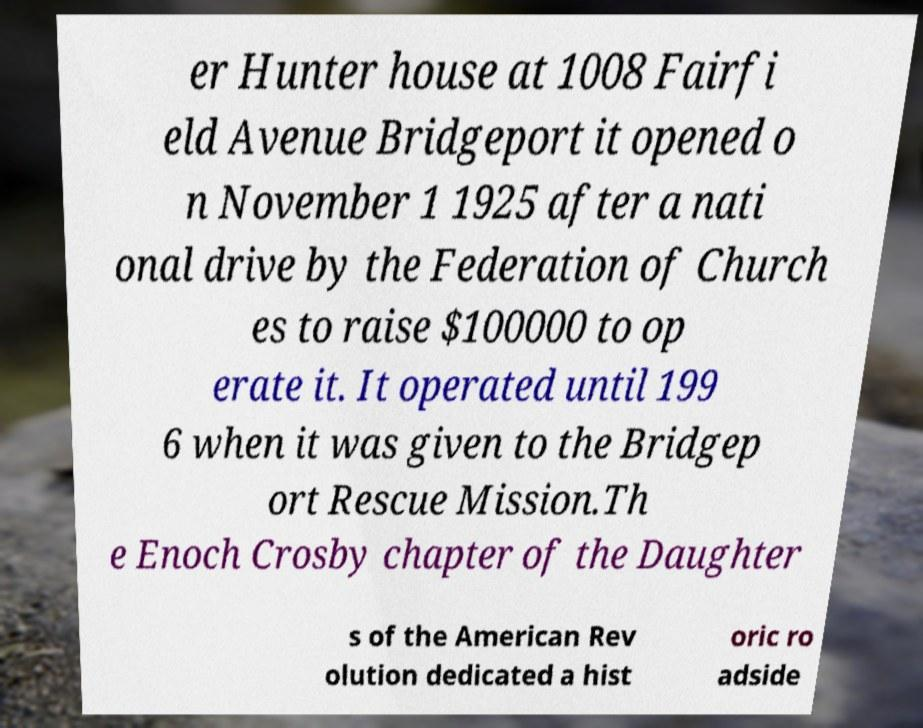What messages or text are displayed in this image? I need them in a readable, typed format. er Hunter house at 1008 Fairfi eld Avenue Bridgeport it opened o n November 1 1925 after a nati onal drive by the Federation of Church es to raise $100000 to op erate it. It operated until 199 6 when it was given to the Bridgep ort Rescue Mission.Th e Enoch Crosby chapter of the Daughter s of the American Rev olution dedicated a hist oric ro adside 